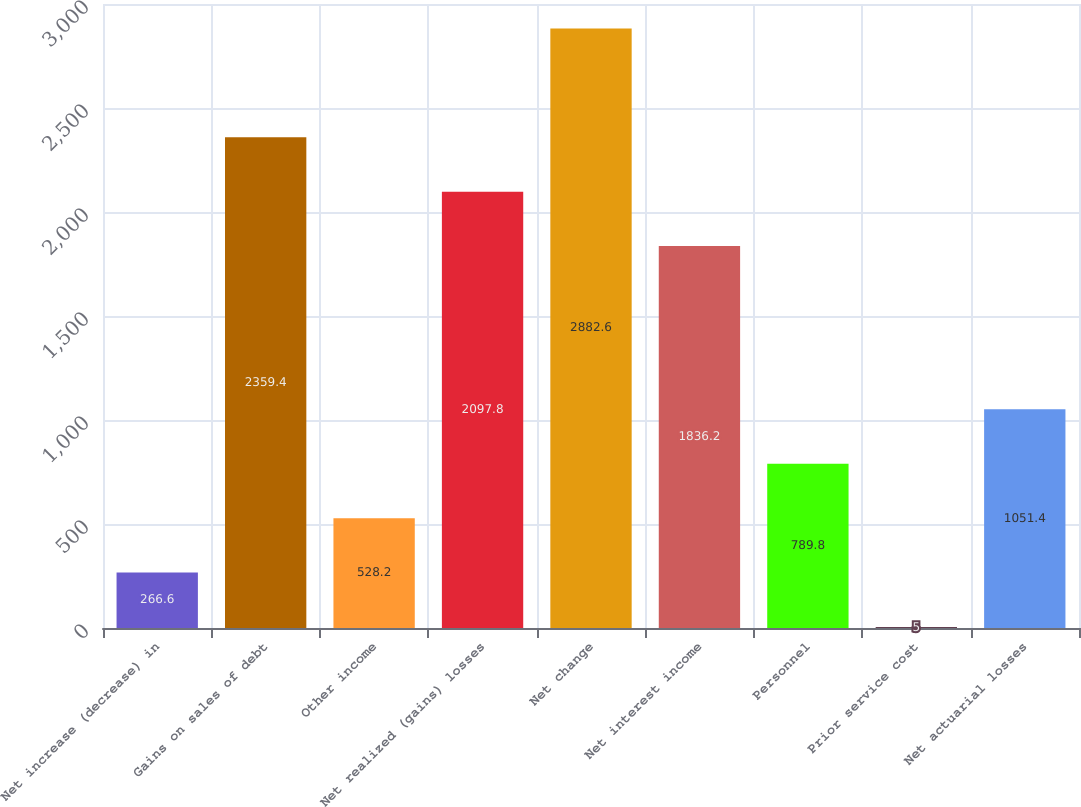<chart> <loc_0><loc_0><loc_500><loc_500><bar_chart><fcel>Net increase (decrease) in<fcel>Gains on sales of debt<fcel>Other income<fcel>Net realized (gains) losses<fcel>Net change<fcel>Net interest income<fcel>Personnel<fcel>Prior service cost<fcel>Net actuarial losses<nl><fcel>266.6<fcel>2359.4<fcel>528.2<fcel>2097.8<fcel>2882.6<fcel>1836.2<fcel>789.8<fcel>5<fcel>1051.4<nl></chart> 